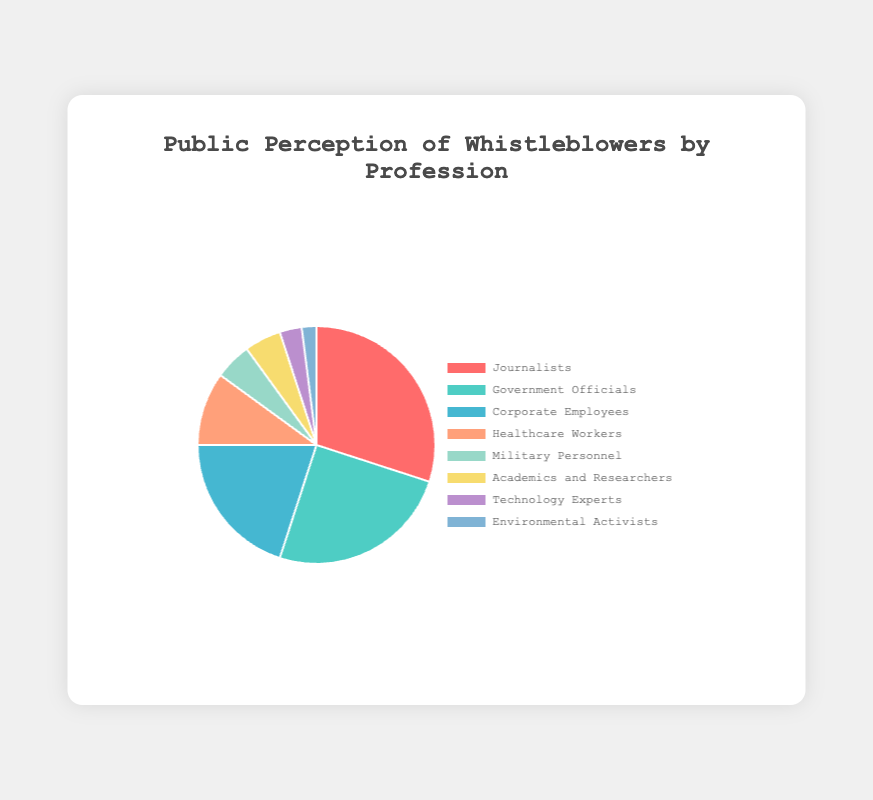Which profession has the highest public perception as whistleblowers? The sector that occupies the largest portion of the pie chart represents the profession with the highest public perception. According to the data, Journalists hold the highest percentage at 30%.
Answer: Journalists Which three professions have the lowest public perception? By observing the smallest segments of the pie chart, the professions with the lowest percentages can be identified. The lowest percentages are represented by Environmental Activists (2%), Technology Experts (3%), and Military Personnel/Academics and Researchers (both 5%).
Answer: Environmental Activists, Technology Experts, Military Personnel, Academics and Researchers Calculate the combined public perception percentage of Government Officials and Corporate Employees. Sum the percentages of Government Officials (25%) and Corporate Employees (20%). The combined percentage is 25% + 20% = 45%.
Answer: 45% How much greater is the perception of Journalists compared to Healthcare Workers? Subtract the perception percentage of Healthcare Workers (10%) from that of Journalists (30%). The difference is 30% - 10% = 20%.
Answer: 20% What is the total percentage representation of professions related to scientific work (Academics and Researchers, Technology Experts, and Environmental Activists)? Sum the percentages of Academics and Researchers (5%), Technology Experts (3%), and Environmental Activists (2%). The total is 5% + 3% + 2% = 10%.
Answer: 10% Which profession’s segment is colored in green? Identify the color segments in the pie chart. The slice representing Technology Experts is colored in green.
Answer: Technology Experts Is there any profession with equal public perception percentages? Compare the percentages. Both Military Personnel and Academics and Researchers have an equal percentage of 5%.
Answer: Yes Which side of the pie chart has more representation, left or right? Sum percentages of the professions on each side and compare. Right side (Government Officials, Military Personnel, Academics and Researchers, Technology Experts, Environmental Activists) sums to 25% + 5% + 5% + 3% + 2% = 40%. Left side (Journalists, Corporate Employees, Healthcare Workers) sums to 30% + 20% + 10% = 60%.
Answer: Left side What is the ratio of the public perception of Corporate Employees to Environmental Activists? Divide the percentage of Corporate Employees (20%) by the percentage of Environmental Activists (2%). The ratio is 20% / 2% = 10.
Answer: 10:1 